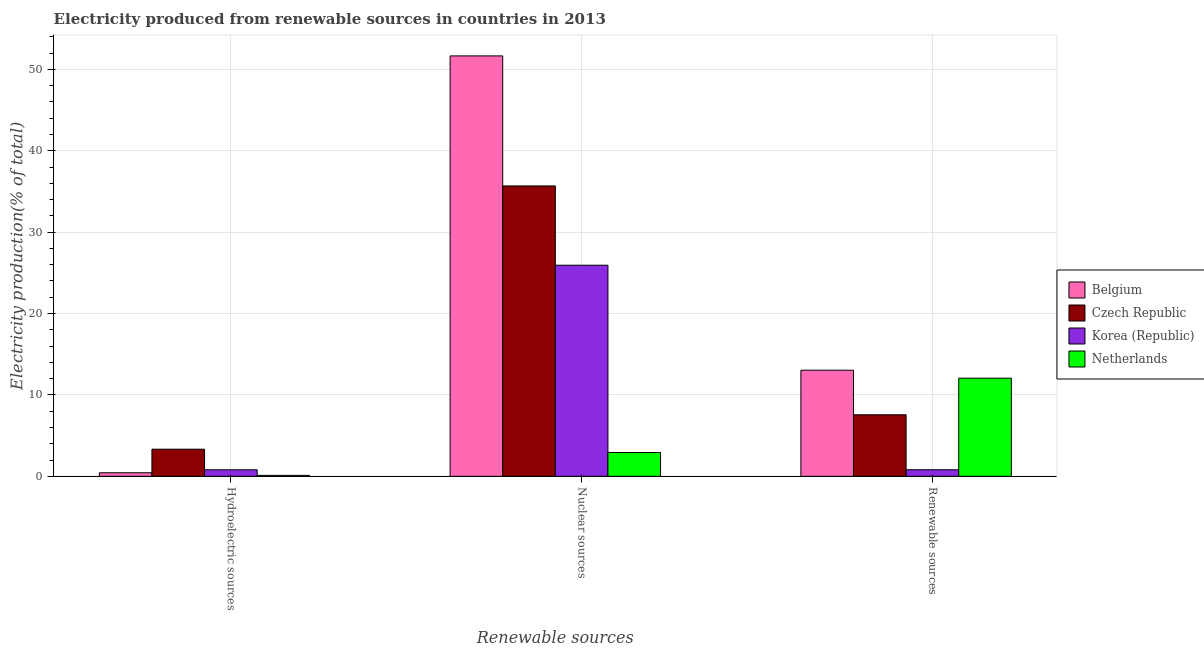How many different coloured bars are there?
Keep it short and to the point. 4. How many bars are there on the 3rd tick from the right?
Give a very brief answer. 4. What is the label of the 3rd group of bars from the left?
Ensure brevity in your answer.  Renewable sources. What is the percentage of electricity produced by renewable sources in Belgium?
Make the answer very short. 13.04. Across all countries, what is the maximum percentage of electricity produced by nuclear sources?
Ensure brevity in your answer.  51.66. Across all countries, what is the minimum percentage of electricity produced by renewable sources?
Provide a succinct answer. 0.81. In which country was the percentage of electricity produced by hydroelectric sources maximum?
Your answer should be very brief. Czech Republic. In which country was the percentage of electricity produced by nuclear sources minimum?
Keep it short and to the point. Netherlands. What is the total percentage of electricity produced by hydroelectric sources in the graph?
Offer a very short reply. 4.69. What is the difference between the percentage of electricity produced by renewable sources in Netherlands and that in Korea (Republic)?
Offer a terse response. 11.25. What is the difference between the percentage of electricity produced by renewable sources in Korea (Republic) and the percentage of electricity produced by nuclear sources in Netherlands?
Give a very brief answer. -2.12. What is the average percentage of electricity produced by nuclear sources per country?
Give a very brief answer. 29.05. What is the difference between the percentage of electricity produced by hydroelectric sources and percentage of electricity produced by nuclear sources in Korea (Republic)?
Your answer should be very brief. -25.14. What is the ratio of the percentage of electricity produced by nuclear sources in Korea (Republic) to that in Czech Republic?
Ensure brevity in your answer.  0.73. Is the percentage of electricity produced by nuclear sources in Belgium less than that in Korea (Republic)?
Provide a short and direct response. No. Is the difference between the percentage of electricity produced by hydroelectric sources in Czech Republic and Korea (Republic) greater than the difference between the percentage of electricity produced by nuclear sources in Czech Republic and Korea (Republic)?
Give a very brief answer. No. What is the difference between the highest and the second highest percentage of electricity produced by hydroelectric sources?
Ensure brevity in your answer.  2.53. What is the difference between the highest and the lowest percentage of electricity produced by hydroelectric sources?
Your answer should be very brief. 3.22. What does the 2nd bar from the left in Renewable sources represents?
Offer a terse response. Czech Republic. Is it the case that in every country, the sum of the percentage of electricity produced by hydroelectric sources and percentage of electricity produced by nuclear sources is greater than the percentage of electricity produced by renewable sources?
Your answer should be very brief. No. How many bars are there?
Keep it short and to the point. 12. Are all the bars in the graph horizontal?
Your answer should be compact. No. How many countries are there in the graph?
Provide a succinct answer. 4. What is the difference between two consecutive major ticks on the Y-axis?
Provide a succinct answer. 10. Are the values on the major ticks of Y-axis written in scientific E-notation?
Keep it short and to the point. No. Does the graph contain any zero values?
Your answer should be very brief. No. Where does the legend appear in the graph?
Give a very brief answer. Center right. How many legend labels are there?
Your response must be concise. 4. How are the legend labels stacked?
Offer a very short reply. Vertical. What is the title of the graph?
Ensure brevity in your answer.  Electricity produced from renewable sources in countries in 2013. What is the label or title of the X-axis?
Keep it short and to the point. Renewable sources. What is the label or title of the Y-axis?
Ensure brevity in your answer.  Electricity production(% of total). What is the Electricity production(% of total) of Belgium in Hydroelectric sources?
Provide a succinct answer. 0.44. What is the Electricity production(% of total) of Czech Republic in Hydroelectric sources?
Provide a succinct answer. 3.33. What is the Electricity production(% of total) of Korea (Republic) in Hydroelectric sources?
Your response must be concise. 0.8. What is the Electricity production(% of total) of Netherlands in Hydroelectric sources?
Provide a short and direct response. 0.12. What is the Electricity production(% of total) in Belgium in Nuclear sources?
Make the answer very short. 51.66. What is the Electricity production(% of total) in Czech Republic in Nuclear sources?
Your answer should be very brief. 35.68. What is the Electricity production(% of total) of Korea (Republic) in Nuclear sources?
Ensure brevity in your answer.  25.94. What is the Electricity production(% of total) of Netherlands in Nuclear sources?
Your response must be concise. 2.93. What is the Electricity production(% of total) in Belgium in Renewable sources?
Your answer should be compact. 13.04. What is the Electricity production(% of total) of Czech Republic in Renewable sources?
Offer a terse response. 7.56. What is the Electricity production(% of total) in Korea (Republic) in Renewable sources?
Provide a succinct answer. 0.81. What is the Electricity production(% of total) of Netherlands in Renewable sources?
Make the answer very short. 12.06. Across all Renewable sources, what is the maximum Electricity production(% of total) of Belgium?
Your response must be concise. 51.66. Across all Renewable sources, what is the maximum Electricity production(% of total) of Czech Republic?
Your answer should be compact. 35.68. Across all Renewable sources, what is the maximum Electricity production(% of total) of Korea (Republic)?
Your response must be concise. 25.94. Across all Renewable sources, what is the maximum Electricity production(% of total) of Netherlands?
Offer a terse response. 12.06. Across all Renewable sources, what is the minimum Electricity production(% of total) in Belgium?
Keep it short and to the point. 0.44. Across all Renewable sources, what is the minimum Electricity production(% of total) of Czech Republic?
Ensure brevity in your answer.  3.33. Across all Renewable sources, what is the minimum Electricity production(% of total) of Korea (Republic)?
Your answer should be very brief. 0.8. Across all Renewable sources, what is the minimum Electricity production(% of total) in Netherlands?
Provide a short and direct response. 0.12. What is the total Electricity production(% of total) in Belgium in the graph?
Keep it short and to the point. 65.13. What is the total Electricity production(% of total) in Czech Republic in the graph?
Make the answer very short. 46.57. What is the total Electricity production(% of total) of Korea (Republic) in the graph?
Offer a terse response. 27.54. What is the total Electricity production(% of total) in Netherlands in the graph?
Your answer should be very brief. 15.1. What is the difference between the Electricity production(% of total) of Belgium in Hydroelectric sources and that in Nuclear sources?
Your answer should be compact. -51.22. What is the difference between the Electricity production(% of total) of Czech Republic in Hydroelectric sources and that in Nuclear sources?
Offer a terse response. -32.34. What is the difference between the Electricity production(% of total) of Korea (Republic) in Hydroelectric sources and that in Nuclear sources?
Ensure brevity in your answer.  -25.14. What is the difference between the Electricity production(% of total) in Netherlands in Hydroelectric sources and that in Nuclear sources?
Keep it short and to the point. -2.81. What is the difference between the Electricity production(% of total) of Belgium in Hydroelectric sources and that in Renewable sources?
Your answer should be compact. -12.6. What is the difference between the Electricity production(% of total) in Czech Republic in Hydroelectric sources and that in Renewable sources?
Offer a terse response. -4.23. What is the difference between the Electricity production(% of total) in Korea (Republic) in Hydroelectric sources and that in Renewable sources?
Give a very brief answer. -0. What is the difference between the Electricity production(% of total) of Netherlands in Hydroelectric sources and that in Renewable sources?
Your response must be concise. -11.94. What is the difference between the Electricity production(% of total) of Belgium in Nuclear sources and that in Renewable sources?
Keep it short and to the point. 38.62. What is the difference between the Electricity production(% of total) in Czech Republic in Nuclear sources and that in Renewable sources?
Provide a short and direct response. 28.12. What is the difference between the Electricity production(% of total) in Korea (Republic) in Nuclear sources and that in Renewable sources?
Keep it short and to the point. 25.13. What is the difference between the Electricity production(% of total) in Netherlands in Nuclear sources and that in Renewable sources?
Ensure brevity in your answer.  -9.13. What is the difference between the Electricity production(% of total) of Belgium in Hydroelectric sources and the Electricity production(% of total) of Czech Republic in Nuclear sources?
Offer a very short reply. -35.24. What is the difference between the Electricity production(% of total) of Belgium in Hydroelectric sources and the Electricity production(% of total) of Korea (Republic) in Nuclear sources?
Your answer should be very brief. -25.5. What is the difference between the Electricity production(% of total) in Belgium in Hydroelectric sources and the Electricity production(% of total) in Netherlands in Nuclear sources?
Ensure brevity in your answer.  -2.49. What is the difference between the Electricity production(% of total) of Czech Republic in Hydroelectric sources and the Electricity production(% of total) of Korea (Republic) in Nuclear sources?
Your answer should be very brief. -22.6. What is the difference between the Electricity production(% of total) of Czech Republic in Hydroelectric sources and the Electricity production(% of total) of Netherlands in Nuclear sources?
Your response must be concise. 0.41. What is the difference between the Electricity production(% of total) of Korea (Republic) in Hydroelectric sources and the Electricity production(% of total) of Netherlands in Nuclear sources?
Ensure brevity in your answer.  -2.13. What is the difference between the Electricity production(% of total) in Belgium in Hydroelectric sources and the Electricity production(% of total) in Czech Republic in Renewable sources?
Your answer should be compact. -7.12. What is the difference between the Electricity production(% of total) of Belgium in Hydroelectric sources and the Electricity production(% of total) of Korea (Republic) in Renewable sources?
Offer a very short reply. -0.37. What is the difference between the Electricity production(% of total) in Belgium in Hydroelectric sources and the Electricity production(% of total) in Netherlands in Renewable sources?
Keep it short and to the point. -11.62. What is the difference between the Electricity production(% of total) in Czech Republic in Hydroelectric sources and the Electricity production(% of total) in Korea (Republic) in Renewable sources?
Keep it short and to the point. 2.53. What is the difference between the Electricity production(% of total) of Czech Republic in Hydroelectric sources and the Electricity production(% of total) of Netherlands in Renewable sources?
Make the answer very short. -8.73. What is the difference between the Electricity production(% of total) of Korea (Republic) in Hydroelectric sources and the Electricity production(% of total) of Netherlands in Renewable sources?
Make the answer very short. -11.26. What is the difference between the Electricity production(% of total) of Belgium in Nuclear sources and the Electricity production(% of total) of Czech Republic in Renewable sources?
Your answer should be compact. 44.1. What is the difference between the Electricity production(% of total) of Belgium in Nuclear sources and the Electricity production(% of total) of Korea (Republic) in Renewable sources?
Offer a very short reply. 50.85. What is the difference between the Electricity production(% of total) of Belgium in Nuclear sources and the Electricity production(% of total) of Netherlands in Renewable sources?
Ensure brevity in your answer.  39.6. What is the difference between the Electricity production(% of total) of Czech Republic in Nuclear sources and the Electricity production(% of total) of Korea (Republic) in Renewable sources?
Make the answer very short. 34.87. What is the difference between the Electricity production(% of total) of Czech Republic in Nuclear sources and the Electricity production(% of total) of Netherlands in Renewable sources?
Your response must be concise. 23.62. What is the difference between the Electricity production(% of total) in Korea (Republic) in Nuclear sources and the Electricity production(% of total) in Netherlands in Renewable sources?
Make the answer very short. 13.88. What is the average Electricity production(% of total) in Belgium per Renewable sources?
Your answer should be compact. 21.71. What is the average Electricity production(% of total) of Czech Republic per Renewable sources?
Give a very brief answer. 15.52. What is the average Electricity production(% of total) in Korea (Republic) per Renewable sources?
Your answer should be compact. 9.18. What is the average Electricity production(% of total) in Netherlands per Renewable sources?
Your answer should be very brief. 5.03. What is the difference between the Electricity production(% of total) of Belgium and Electricity production(% of total) of Czech Republic in Hydroelectric sources?
Your answer should be very brief. -2.9. What is the difference between the Electricity production(% of total) in Belgium and Electricity production(% of total) in Korea (Republic) in Hydroelectric sources?
Provide a succinct answer. -0.36. What is the difference between the Electricity production(% of total) of Belgium and Electricity production(% of total) of Netherlands in Hydroelectric sources?
Provide a short and direct response. 0.32. What is the difference between the Electricity production(% of total) of Czech Republic and Electricity production(% of total) of Korea (Republic) in Hydroelectric sources?
Offer a terse response. 2.53. What is the difference between the Electricity production(% of total) of Czech Republic and Electricity production(% of total) of Netherlands in Hydroelectric sources?
Offer a terse response. 3.22. What is the difference between the Electricity production(% of total) of Korea (Republic) and Electricity production(% of total) of Netherlands in Hydroelectric sources?
Provide a short and direct response. 0.69. What is the difference between the Electricity production(% of total) in Belgium and Electricity production(% of total) in Czech Republic in Nuclear sources?
Make the answer very short. 15.98. What is the difference between the Electricity production(% of total) of Belgium and Electricity production(% of total) of Korea (Republic) in Nuclear sources?
Your response must be concise. 25.72. What is the difference between the Electricity production(% of total) of Belgium and Electricity production(% of total) of Netherlands in Nuclear sources?
Provide a short and direct response. 48.73. What is the difference between the Electricity production(% of total) of Czech Republic and Electricity production(% of total) of Korea (Republic) in Nuclear sources?
Your answer should be compact. 9.74. What is the difference between the Electricity production(% of total) in Czech Republic and Electricity production(% of total) in Netherlands in Nuclear sources?
Offer a terse response. 32.75. What is the difference between the Electricity production(% of total) of Korea (Republic) and Electricity production(% of total) of Netherlands in Nuclear sources?
Offer a very short reply. 23.01. What is the difference between the Electricity production(% of total) of Belgium and Electricity production(% of total) of Czech Republic in Renewable sources?
Offer a terse response. 5.48. What is the difference between the Electricity production(% of total) of Belgium and Electricity production(% of total) of Korea (Republic) in Renewable sources?
Provide a short and direct response. 12.23. What is the difference between the Electricity production(% of total) in Belgium and Electricity production(% of total) in Netherlands in Renewable sources?
Keep it short and to the point. 0.98. What is the difference between the Electricity production(% of total) in Czech Republic and Electricity production(% of total) in Korea (Republic) in Renewable sources?
Keep it short and to the point. 6.75. What is the difference between the Electricity production(% of total) in Czech Republic and Electricity production(% of total) in Netherlands in Renewable sources?
Offer a very short reply. -4.5. What is the difference between the Electricity production(% of total) of Korea (Republic) and Electricity production(% of total) of Netherlands in Renewable sources?
Offer a very short reply. -11.25. What is the ratio of the Electricity production(% of total) of Belgium in Hydroelectric sources to that in Nuclear sources?
Your response must be concise. 0.01. What is the ratio of the Electricity production(% of total) of Czech Republic in Hydroelectric sources to that in Nuclear sources?
Offer a terse response. 0.09. What is the ratio of the Electricity production(% of total) in Korea (Republic) in Hydroelectric sources to that in Nuclear sources?
Your answer should be very brief. 0.03. What is the ratio of the Electricity production(% of total) in Netherlands in Hydroelectric sources to that in Nuclear sources?
Give a very brief answer. 0.04. What is the ratio of the Electricity production(% of total) in Belgium in Hydroelectric sources to that in Renewable sources?
Offer a very short reply. 0.03. What is the ratio of the Electricity production(% of total) in Czech Republic in Hydroelectric sources to that in Renewable sources?
Your answer should be compact. 0.44. What is the ratio of the Electricity production(% of total) in Korea (Republic) in Hydroelectric sources to that in Renewable sources?
Your answer should be compact. 0.99. What is the ratio of the Electricity production(% of total) of Netherlands in Hydroelectric sources to that in Renewable sources?
Make the answer very short. 0.01. What is the ratio of the Electricity production(% of total) of Belgium in Nuclear sources to that in Renewable sources?
Provide a short and direct response. 3.96. What is the ratio of the Electricity production(% of total) of Czech Republic in Nuclear sources to that in Renewable sources?
Ensure brevity in your answer.  4.72. What is the ratio of the Electricity production(% of total) of Korea (Republic) in Nuclear sources to that in Renewable sources?
Provide a succinct answer. 32.19. What is the ratio of the Electricity production(% of total) of Netherlands in Nuclear sources to that in Renewable sources?
Your response must be concise. 0.24. What is the difference between the highest and the second highest Electricity production(% of total) in Belgium?
Make the answer very short. 38.62. What is the difference between the highest and the second highest Electricity production(% of total) in Czech Republic?
Your answer should be very brief. 28.12. What is the difference between the highest and the second highest Electricity production(% of total) in Korea (Republic)?
Provide a short and direct response. 25.13. What is the difference between the highest and the second highest Electricity production(% of total) in Netherlands?
Keep it short and to the point. 9.13. What is the difference between the highest and the lowest Electricity production(% of total) of Belgium?
Your answer should be very brief. 51.22. What is the difference between the highest and the lowest Electricity production(% of total) in Czech Republic?
Provide a short and direct response. 32.34. What is the difference between the highest and the lowest Electricity production(% of total) in Korea (Republic)?
Keep it short and to the point. 25.14. What is the difference between the highest and the lowest Electricity production(% of total) of Netherlands?
Keep it short and to the point. 11.94. 